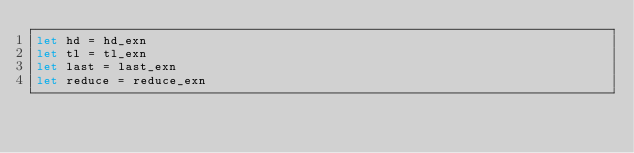Convert code to text. <code><loc_0><loc_0><loc_500><loc_500><_OCaml_>let hd = hd_exn
let tl = tl_exn
let last = last_exn
let reduce = reduce_exn
</code> 